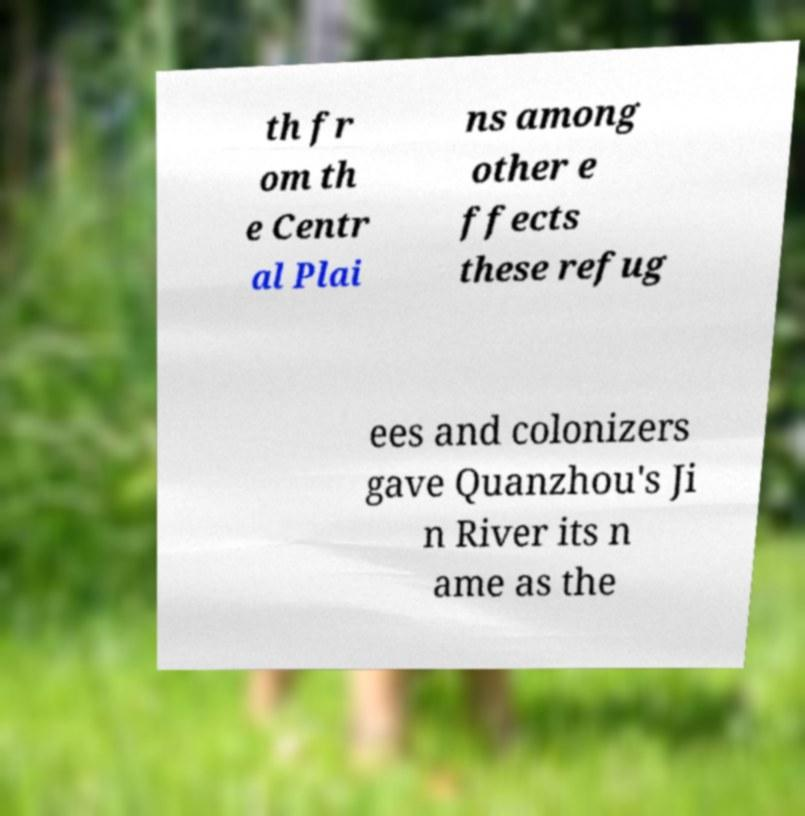What messages or text are displayed in this image? I need them in a readable, typed format. th fr om th e Centr al Plai ns among other e ffects these refug ees and colonizers gave Quanzhou's Ji n River its n ame as the 